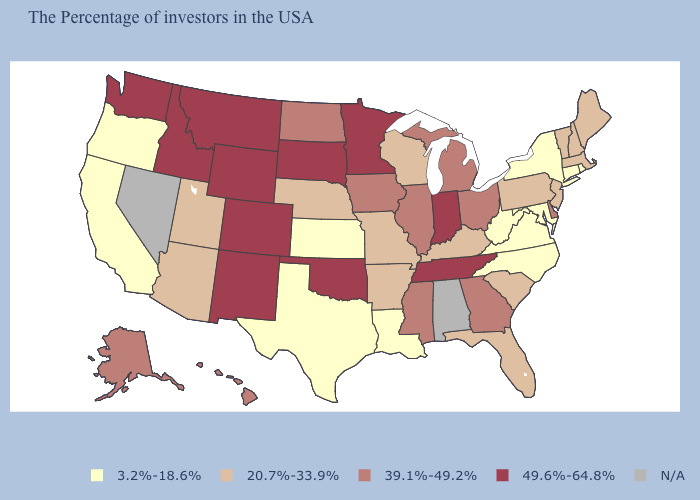Name the states that have a value in the range N/A?
Write a very short answer. Alabama, Nevada. What is the value of Oregon?
Give a very brief answer. 3.2%-18.6%. What is the value of Maine?
Answer briefly. 20.7%-33.9%. What is the lowest value in the USA?
Be succinct. 3.2%-18.6%. What is the lowest value in states that border Massachusetts?
Short answer required. 3.2%-18.6%. How many symbols are there in the legend?
Concise answer only. 5. What is the value of Colorado?
Answer briefly. 49.6%-64.8%. Among the states that border Maryland , does Pennsylvania have the highest value?
Short answer required. No. What is the highest value in the West ?
Short answer required. 49.6%-64.8%. Among the states that border Montana , which have the highest value?
Write a very short answer. South Dakota, Wyoming, Idaho. Name the states that have a value in the range N/A?
Keep it brief. Alabama, Nevada. What is the highest value in the USA?
Write a very short answer. 49.6%-64.8%. Name the states that have a value in the range 20.7%-33.9%?
Short answer required. Maine, Massachusetts, New Hampshire, Vermont, New Jersey, Pennsylvania, South Carolina, Florida, Kentucky, Wisconsin, Missouri, Arkansas, Nebraska, Utah, Arizona. 